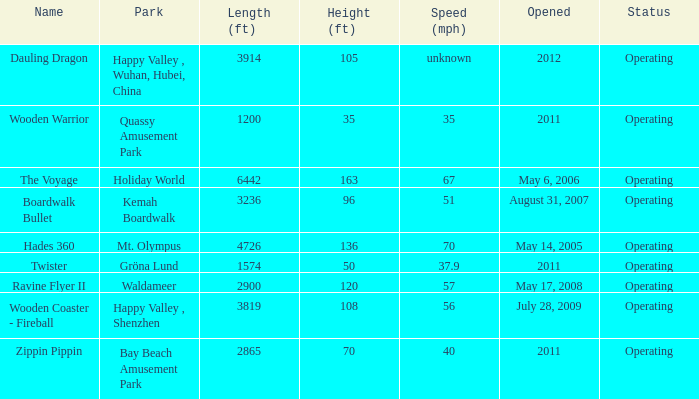How long is the rollar coaster on Kemah Boardwalk 3236.0. 